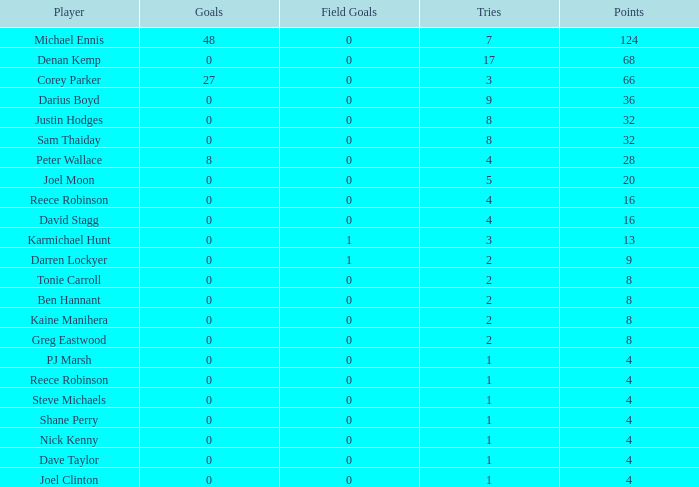What is the total number of field goals of Denan Kemp, who has more than 4 tries, more than 32 points, and 0 goals? 1.0. 